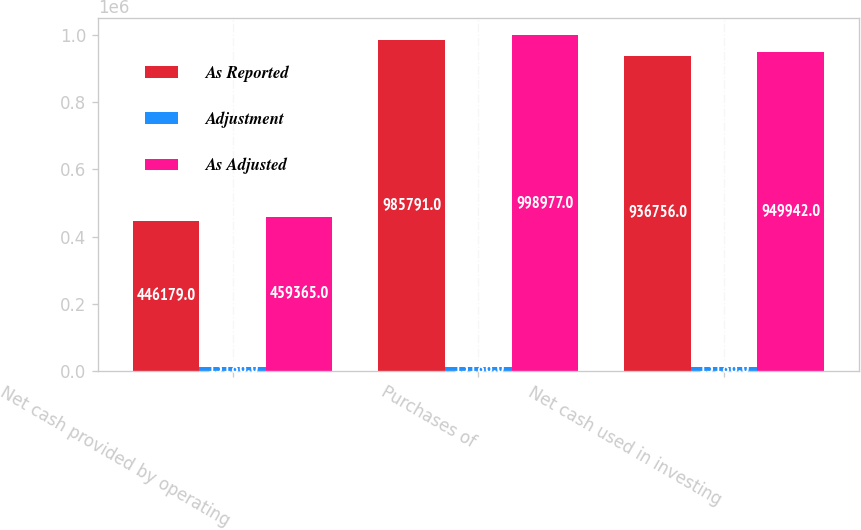Convert chart. <chart><loc_0><loc_0><loc_500><loc_500><stacked_bar_chart><ecel><fcel>Net cash provided by operating<fcel>Purchases of<fcel>Net cash used in investing<nl><fcel>As Reported<fcel>446179<fcel>985791<fcel>936756<nl><fcel>Adjustment<fcel>13186<fcel>13186<fcel>13186<nl><fcel>As Adjusted<fcel>459365<fcel>998977<fcel>949942<nl></chart> 